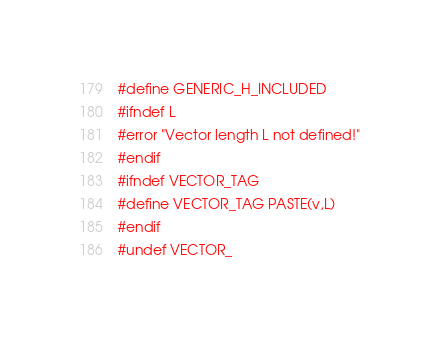<code> <loc_0><loc_0><loc_500><loc_500><_C_>#define GENERIC_H_INCLUDED
#ifndef L
#error "Vector length L not defined!"
#endif
#ifndef VECTOR_TAG
#define VECTOR_TAG PASTE(v,L)
#endif
#undef VECTOR_</code> 